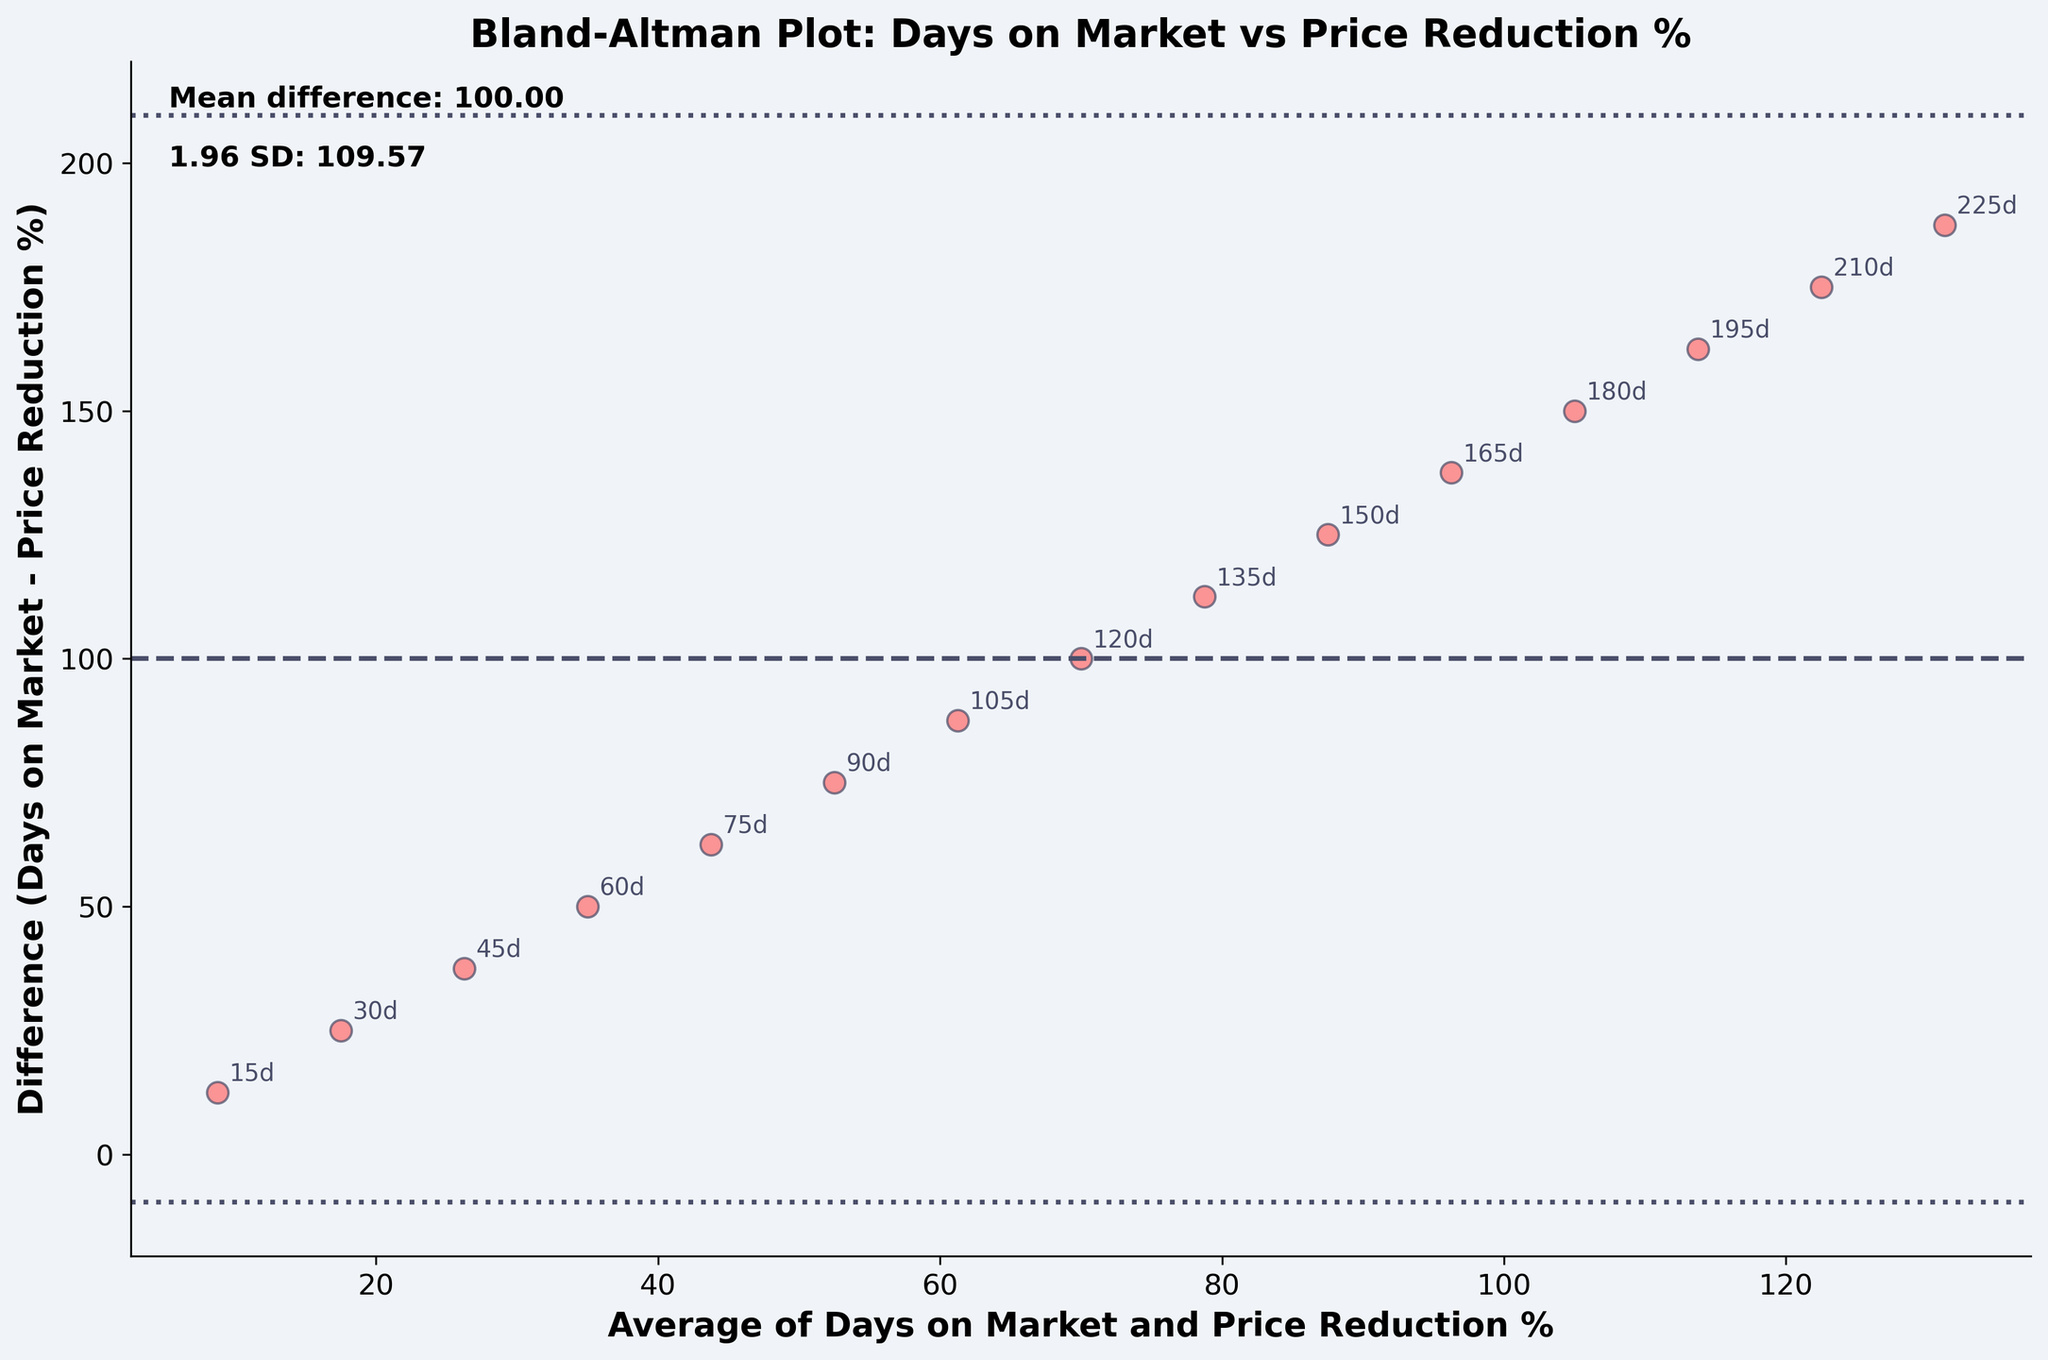What is the title of the plot? The title of the plot is displayed at the top center of the figure.
Answer: Bland-Altman Plot: Days on Market vs Price Reduction % How many data points are plotted in the figure? Each data point pairs the average of days on market and price reduction percentage. Count the number of points.
Answer: 15 What are the x and y-axis labels? The axes are labeled to indicate what they represent. The x-axis label is below the horizontal axis, and the y-axis label is beside the vertical axis.
Answer: Average of Days on Market and Price Reduction %, Difference (Days on Market - Price Reduction %) What is the mean difference noted in the plot? The mean difference is shown as a text on the plot, typically near a horizontal line that it represents.
Answer: 83.75 What does the horizontal dashed line represent? This line shows the mean difference across all data points plotted. It is labeled on the figure.
Answer: Mean difference What colors are used for the data points and the horizontal lines? The data points and lines each have a specific color which can be observed visually in the plot.
Answer: Data points: red, Lines: dark purple What is the value of the 1.96 SD as noted in the plot? The 1.96 SD value is provided directly on the figure as text.
Answer: 57.64 What is the difference for the data point with the highest average? To find this, locate the point with the highest x-value on the x-axis and read off the corresponding y-value.
Answer: 92.5 Which data point has a price reduction percentage of 25% and what is its difference? Identify the point where the reduction percentage is 25% (which corresponds to a specific average value), and look at its difference from the y-axis.
Answer: 150d, 62.5 Are most of the differences within the range of the mean difference ± 1.96 SD? Compare the majority of the data points' differences to the lines representing the mean difference plus or minus 1.96 standard deviations.
Answer: Yes 